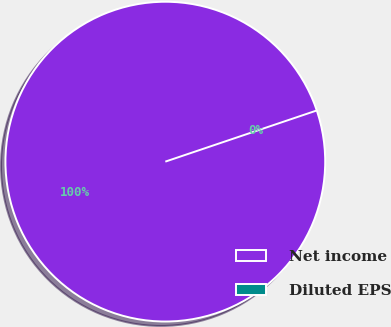Convert chart. <chart><loc_0><loc_0><loc_500><loc_500><pie_chart><fcel>Net income<fcel>Diluted EPS<nl><fcel>100.0%<fcel>0.0%<nl></chart> 